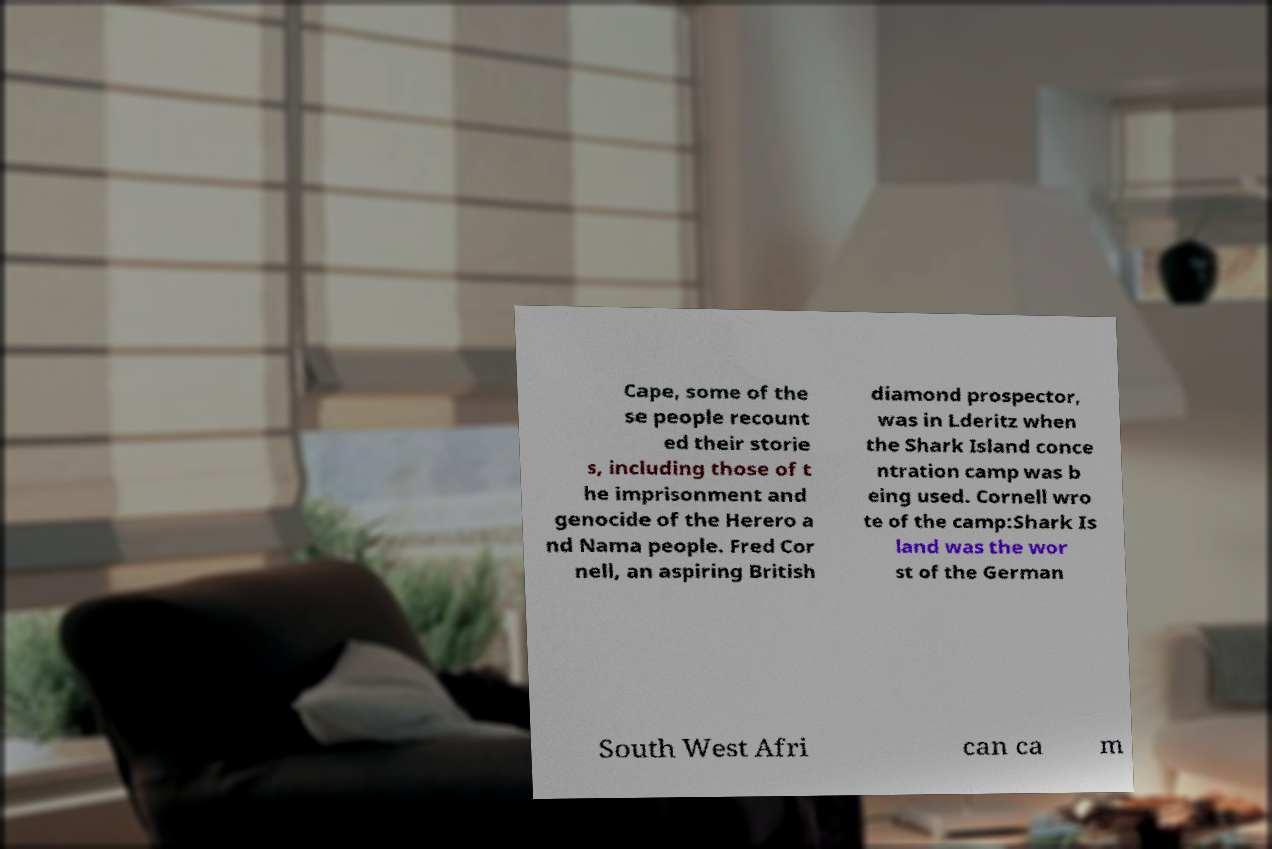For documentation purposes, I need the text within this image transcribed. Could you provide that? Cape, some of the se people recount ed their storie s, including those of t he imprisonment and genocide of the Herero a nd Nama people. Fred Cor nell, an aspiring British diamond prospector, was in Lderitz when the Shark Island conce ntration camp was b eing used. Cornell wro te of the camp:Shark Is land was the wor st of the German South West Afri can ca m 